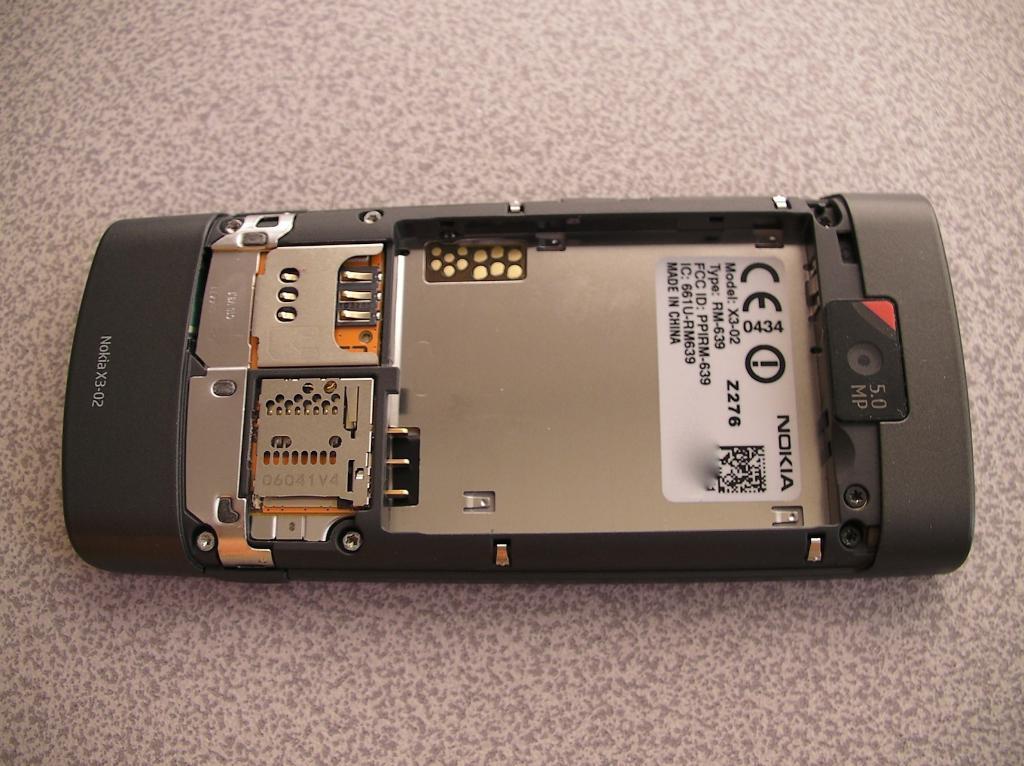Describe this image in one or two sentences. In this image we can see a mobile phone with no batter, sim cards and a memory cards on a platform. 